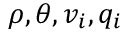Convert formula to latex. <formula><loc_0><loc_0><loc_500><loc_500>\rho , \theta , v _ { i } , q _ { i }</formula> 